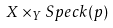<formula> <loc_0><loc_0><loc_500><loc_500>X \times _ { Y } S p e c k ( p )</formula> 